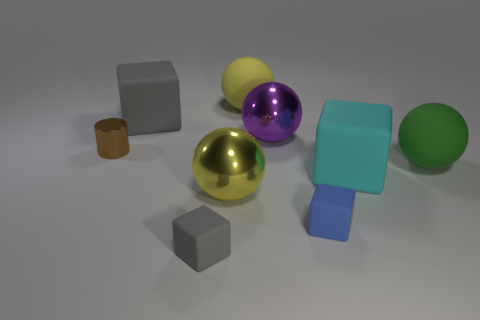Subtract all cylinders. How many objects are left? 8 Subtract all tiny green cubes. Subtract all tiny brown cylinders. How many objects are left? 8 Add 3 tiny gray matte objects. How many tiny gray matte objects are left? 4 Add 1 large gray rubber objects. How many large gray rubber objects exist? 2 Subtract 0 brown balls. How many objects are left? 9 